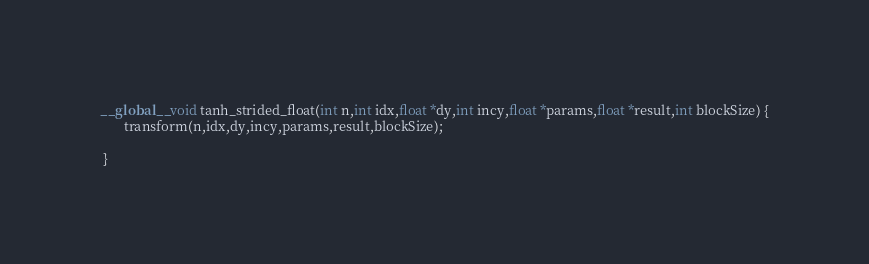Convert code to text. <code><loc_0><loc_0><loc_500><loc_500><_Cuda_>__global__ void tanh_strided_float(int n,int idx,float *dy,int incy,float *params,float *result,int blockSize) {
       transform(n,idx,dy,incy,params,result,blockSize);

 }</code> 